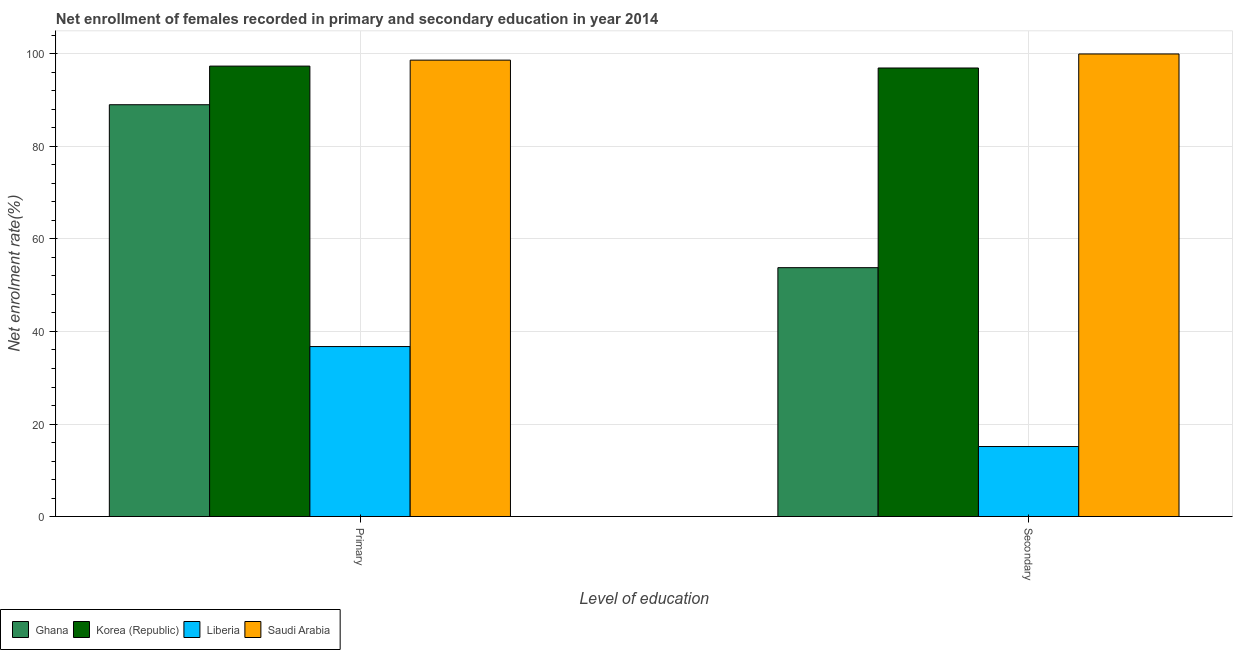How many different coloured bars are there?
Provide a short and direct response. 4. Are the number of bars per tick equal to the number of legend labels?
Give a very brief answer. Yes. Are the number of bars on each tick of the X-axis equal?
Your answer should be very brief. Yes. How many bars are there on the 2nd tick from the left?
Offer a terse response. 4. What is the label of the 1st group of bars from the left?
Provide a succinct answer. Primary. What is the enrollment rate in secondary education in Ghana?
Offer a terse response. 53.8. Across all countries, what is the maximum enrollment rate in primary education?
Your response must be concise. 98.66. Across all countries, what is the minimum enrollment rate in primary education?
Offer a terse response. 36.74. In which country was the enrollment rate in secondary education maximum?
Give a very brief answer. Saudi Arabia. In which country was the enrollment rate in secondary education minimum?
Make the answer very short. Liberia. What is the total enrollment rate in secondary education in the graph?
Make the answer very short. 265.9. What is the difference between the enrollment rate in secondary education in Liberia and that in Saudi Arabia?
Give a very brief answer. -84.87. What is the difference between the enrollment rate in primary education in Saudi Arabia and the enrollment rate in secondary education in Ghana?
Your answer should be compact. 44.86. What is the average enrollment rate in primary education per country?
Provide a short and direct response. 80.45. What is the difference between the enrollment rate in secondary education and enrollment rate in primary education in Ghana?
Offer a very short reply. -35.22. What is the ratio of the enrollment rate in primary education in Ghana to that in Saudi Arabia?
Give a very brief answer. 0.9. Is the enrollment rate in primary education in Korea (Republic) less than that in Liberia?
Offer a very short reply. No. In how many countries, is the enrollment rate in secondary education greater than the average enrollment rate in secondary education taken over all countries?
Offer a very short reply. 2. What does the 2nd bar from the right in Secondary represents?
Your response must be concise. Liberia. How many bars are there?
Offer a terse response. 8. Are all the bars in the graph horizontal?
Keep it short and to the point. No. How many countries are there in the graph?
Your response must be concise. 4. What is the difference between two consecutive major ticks on the Y-axis?
Keep it short and to the point. 20. Does the graph contain grids?
Your answer should be very brief. Yes. What is the title of the graph?
Your response must be concise. Net enrollment of females recorded in primary and secondary education in year 2014. Does "Bahrain" appear as one of the legend labels in the graph?
Offer a very short reply. No. What is the label or title of the X-axis?
Offer a terse response. Level of education. What is the label or title of the Y-axis?
Your response must be concise. Net enrolment rate(%). What is the Net enrolment rate(%) in Ghana in Primary?
Provide a short and direct response. 89.03. What is the Net enrolment rate(%) in Korea (Republic) in Primary?
Your answer should be compact. 97.38. What is the Net enrolment rate(%) in Liberia in Primary?
Offer a terse response. 36.74. What is the Net enrolment rate(%) in Saudi Arabia in Primary?
Your answer should be compact. 98.66. What is the Net enrolment rate(%) in Ghana in Secondary?
Offer a terse response. 53.8. What is the Net enrolment rate(%) in Korea (Republic) in Secondary?
Offer a terse response. 96.96. What is the Net enrolment rate(%) in Liberia in Secondary?
Provide a succinct answer. 15.13. Across all Level of education, what is the maximum Net enrolment rate(%) of Ghana?
Make the answer very short. 89.03. Across all Level of education, what is the maximum Net enrolment rate(%) of Korea (Republic)?
Give a very brief answer. 97.38. Across all Level of education, what is the maximum Net enrolment rate(%) in Liberia?
Your answer should be compact. 36.74. Across all Level of education, what is the minimum Net enrolment rate(%) in Ghana?
Keep it short and to the point. 53.8. Across all Level of education, what is the minimum Net enrolment rate(%) of Korea (Republic)?
Your answer should be very brief. 96.96. Across all Level of education, what is the minimum Net enrolment rate(%) in Liberia?
Give a very brief answer. 15.13. Across all Level of education, what is the minimum Net enrolment rate(%) in Saudi Arabia?
Give a very brief answer. 98.66. What is the total Net enrolment rate(%) in Ghana in the graph?
Provide a short and direct response. 142.83. What is the total Net enrolment rate(%) of Korea (Republic) in the graph?
Provide a succinct answer. 194.34. What is the total Net enrolment rate(%) in Liberia in the graph?
Provide a short and direct response. 51.88. What is the total Net enrolment rate(%) of Saudi Arabia in the graph?
Your response must be concise. 198.66. What is the difference between the Net enrolment rate(%) of Ghana in Primary and that in Secondary?
Your response must be concise. 35.22. What is the difference between the Net enrolment rate(%) of Korea (Republic) in Primary and that in Secondary?
Give a very brief answer. 0.41. What is the difference between the Net enrolment rate(%) of Liberia in Primary and that in Secondary?
Your response must be concise. 21.61. What is the difference between the Net enrolment rate(%) in Saudi Arabia in Primary and that in Secondary?
Your answer should be compact. -1.34. What is the difference between the Net enrolment rate(%) of Ghana in Primary and the Net enrolment rate(%) of Korea (Republic) in Secondary?
Your answer should be compact. -7.94. What is the difference between the Net enrolment rate(%) in Ghana in Primary and the Net enrolment rate(%) in Liberia in Secondary?
Provide a succinct answer. 73.89. What is the difference between the Net enrolment rate(%) of Ghana in Primary and the Net enrolment rate(%) of Saudi Arabia in Secondary?
Provide a short and direct response. -10.97. What is the difference between the Net enrolment rate(%) in Korea (Republic) in Primary and the Net enrolment rate(%) in Liberia in Secondary?
Make the answer very short. 82.24. What is the difference between the Net enrolment rate(%) of Korea (Republic) in Primary and the Net enrolment rate(%) of Saudi Arabia in Secondary?
Offer a very short reply. -2.62. What is the difference between the Net enrolment rate(%) of Liberia in Primary and the Net enrolment rate(%) of Saudi Arabia in Secondary?
Your answer should be compact. -63.26. What is the average Net enrolment rate(%) in Ghana per Level of education?
Offer a terse response. 71.41. What is the average Net enrolment rate(%) of Korea (Republic) per Level of education?
Ensure brevity in your answer.  97.17. What is the average Net enrolment rate(%) in Liberia per Level of education?
Ensure brevity in your answer.  25.94. What is the average Net enrolment rate(%) of Saudi Arabia per Level of education?
Give a very brief answer. 99.33. What is the difference between the Net enrolment rate(%) in Ghana and Net enrolment rate(%) in Korea (Republic) in Primary?
Make the answer very short. -8.35. What is the difference between the Net enrolment rate(%) of Ghana and Net enrolment rate(%) of Liberia in Primary?
Ensure brevity in your answer.  52.28. What is the difference between the Net enrolment rate(%) of Ghana and Net enrolment rate(%) of Saudi Arabia in Primary?
Provide a short and direct response. -9.64. What is the difference between the Net enrolment rate(%) in Korea (Republic) and Net enrolment rate(%) in Liberia in Primary?
Provide a short and direct response. 60.63. What is the difference between the Net enrolment rate(%) in Korea (Republic) and Net enrolment rate(%) in Saudi Arabia in Primary?
Your response must be concise. -1.29. What is the difference between the Net enrolment rate(%) in Liberia and Net enrolment rate(%) in Saudi Arabia in Primary?
Ensure brevity in your answer.  -61.92. What is the difference between the Net enrolment rate(%) in Ghana and Net enrolment rate(%) in Korea (Republic) in Secondary?
Give a very brief answer. -43.16. What is the difference between the Net enrolment rate(%) in Ghana and Net enrolment rate(%) in Liberia in Secondary?
Keep it short and to the point. 38.67. What is the difference between the Net enrolment rate(%) of Ghana and Net enrolment rate(%) of Saudi Arabia in Secondary?
Offer a very short reply. -46.2. What is the difference between the Net enrolment rate(%) in Korea (Republic) and Net enrolment rate(%) in Liberia in Secondary?
Provide a succinct answer. 81.83. What is the difference between the Net enrolment rate(%) of Korea (Republic) and Net enrolment rate(%) of Saudi Arabia in Secondary?
Give a very brief answer. -3.04. What is the difference between the Net enrolment rate(%) in Liberia and Net enrolment rate(%) in Saudi Arabia in Secondary?
Offer a very short reply. -84.87. What is the ratio of the Net enrolment rate(%) in Ghana in Primary to that in Secondary?
Ensure brevity in your answer.  1.65. What is the ratio of the Net enrolment rate(%) in Korea (Republic) in Primary to that in Secondary?
Make the answer very short. 1. What is the ratio of the Net enrolment rate(%) of Liberia in Primary to that in Secondary?
Your answer should be very brief. 2.43. What is the ratio of the Net enrolment rate(%) in Saudi Arabia in Primary to that in Secondary?
Your response must be concise. 0.99. What is the difference between the highest and the second highest Net enrolment rate(%) in Ghana?
Offer a terse response. 35.22. What is the difference between the highest and the second highest Net enrolment rate(%) in Korea (Republic)?
Make the answer very short. 0.41. What is the difference between the highest and the second highest Net enrolment rate(%) in Liberia?
Your answer should be compact. 21.61. What is the difference between the highest and the second highest Net enrolment rate(%) in Saudi Arabia?
Your response must be concise. 1.34. What is the difference between the highest and the lowest Net enrolment rate(%) of Ghana?
Provide a succinct answer. 35.22. What is the difference between the highest and the lowest Net enrolment rate(%) of Korea (Republic)?
Keep it short and to the point. 0.41. What is the difference between the highest and the lowest Net enrolment rate(%) of Liberia?
Your response must be concise. 21.61. What is the difference between the highest and the lowest Net enrolment rate(%) in Saudi Arabia?
Provide a short and direct response. 1.34. 